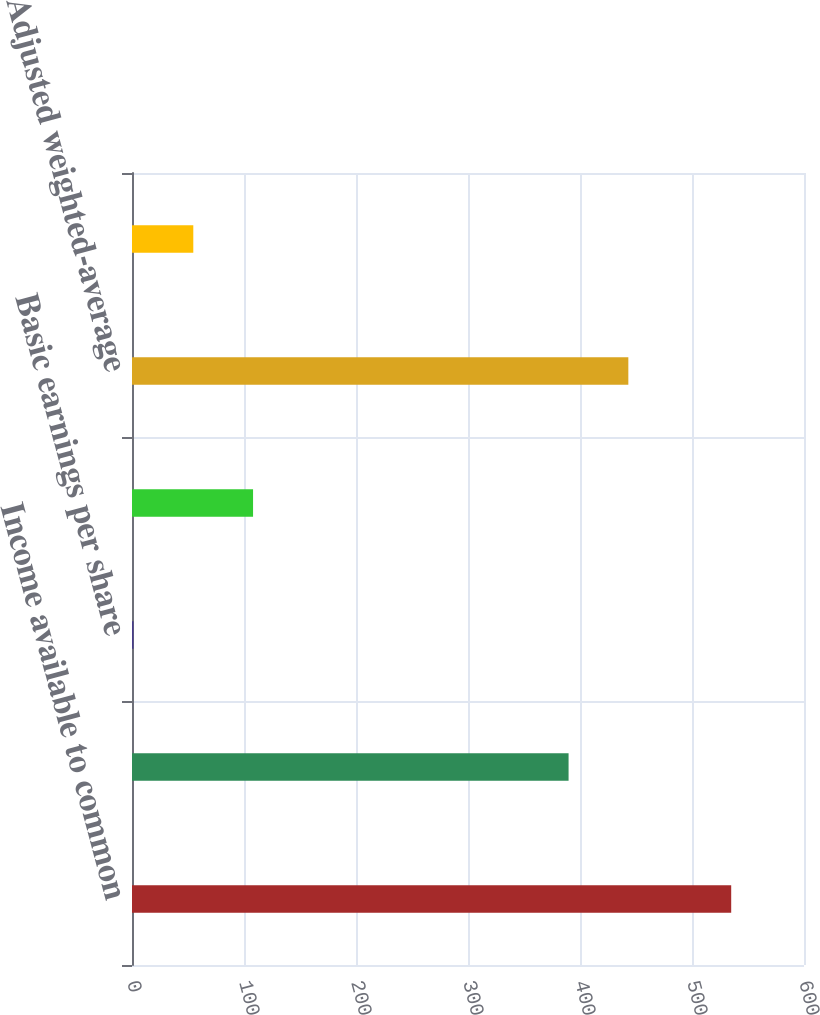Convert chart. <chart><loc_0><loc_0><loc_500><loc_500><bar_chart><fcel>Income available to common<fcel>Weighted-average shares<fcel>Basic earnings per share<fcel>Dilutive effect of outstanding<fcel>Adjusted weighted-average<fcel>Diluted earnings per share<nl><fcel>535<fcel>389.8<fcel>1.37<fcel>108.09<fcel>443.16<fcel>54.73<nl></chart> 